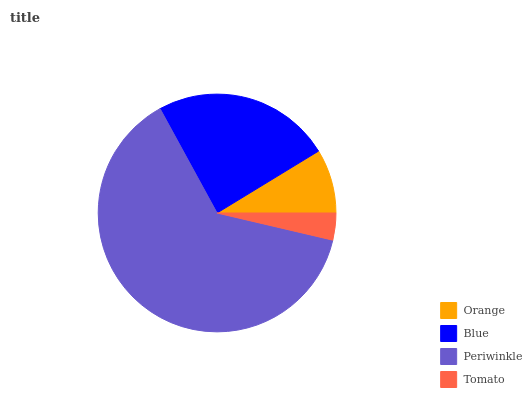Is Tomato the minimum?
Answer yes or no. Yes. Is Periwinkle the maximum?
Answer yes or no. Yes. Is Blue the minimum?
Answer yes or no. No. Is Blue the maximum?
Answer yes or no. No. Is Blue greater than Orange?
Answer yes or no. Yes. Is Orange less than Blue?
Answer yes or no. Yes. Is Orange greater than Blue?
Answer yes or no. No. Is Blue less than Orange?
Answer yes or no. No. Is Blue the high median?
Answer yes or no. Yes. Is Orange the low median?
Answer yes or no. Yes. Is Orange the high median?
Answer yes or no. No. Is Tomato the low median?
Answer yes or no. No. 